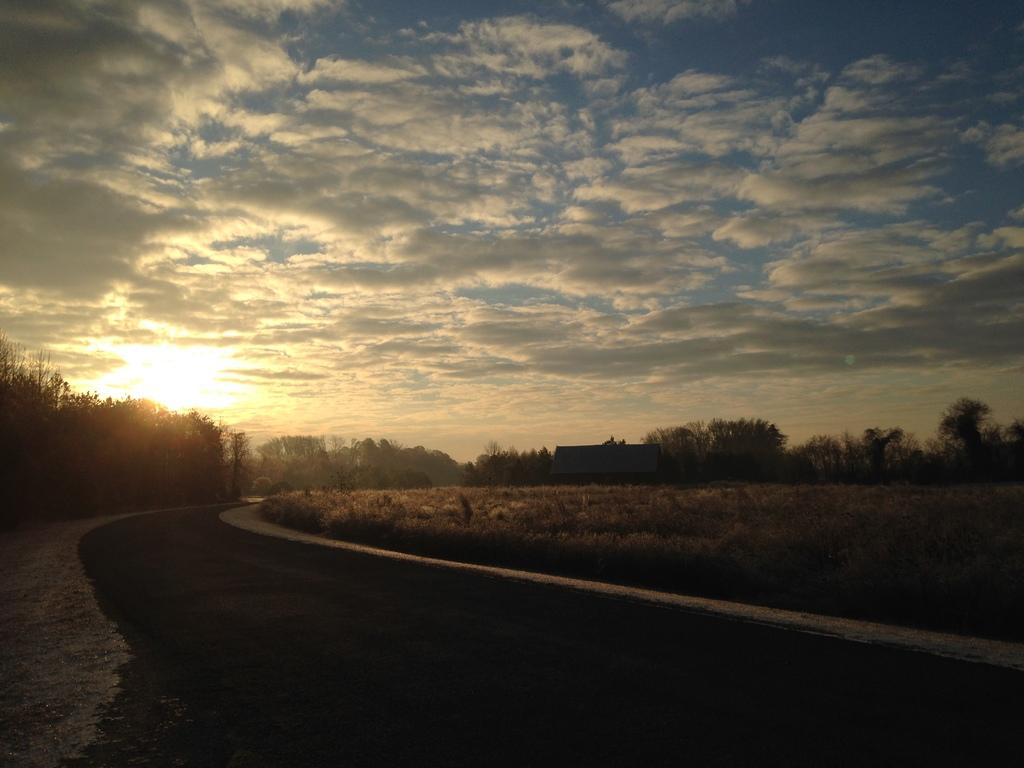What is located at the bottom of the image? There is a road at the bottom of the image. What can be seen near the road? There are plants near the road. What is visible in the background of the image? There are trees and one house in the background of the image. What is visible at the top of the image? The sky is visible at the top of the image. Can you see any writing on the road in the image? There is no writing visible on the road in the image. Is there a harbor present in the image? There is no harbor present in the image. 